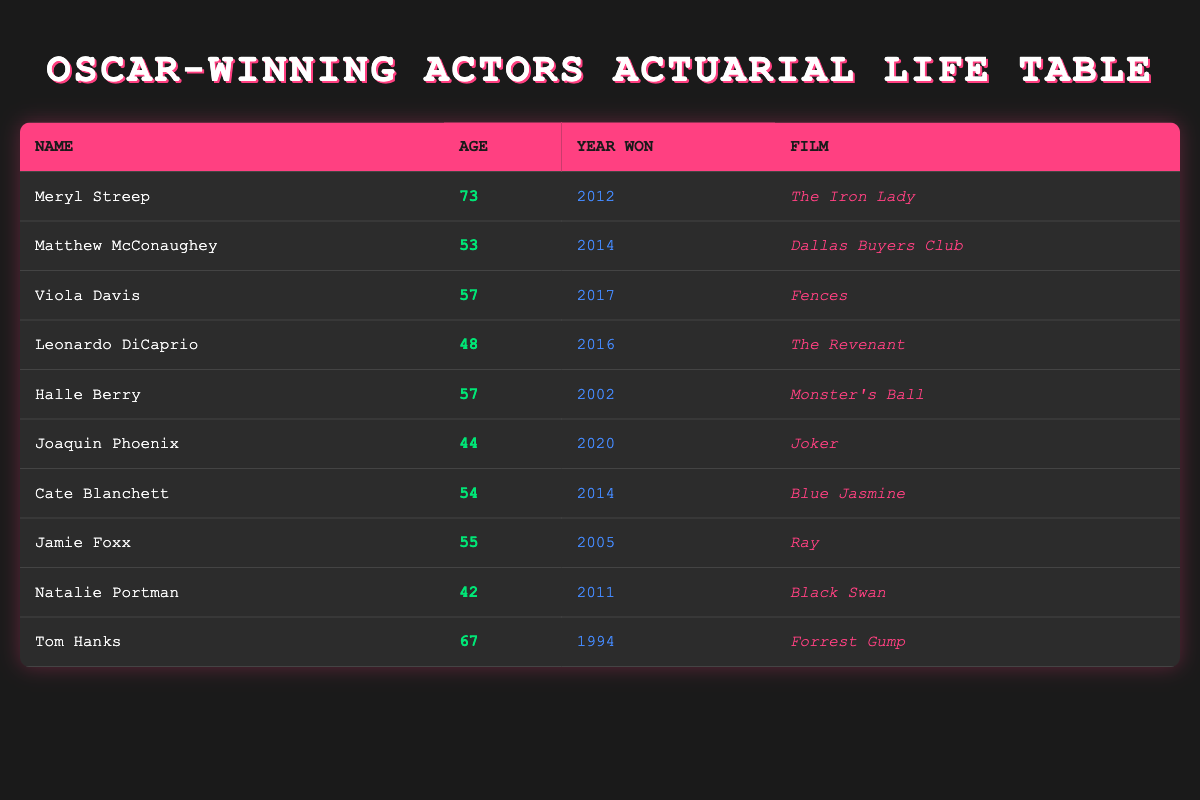What is the age of Meryl Streep when she won her Oscar? Meryl Streep's age is listed in the table as 73, which is directly taken from the "Age" column next to her name.
Answer: 73 Which film did Matthew McConaughey win his Oscar for? The table indicates that Matthew McConaughey won his Oscar for "Dallas Buyers Club", found in the "Film" column next to his name.
Answer: Dallas Buyers Club How many Oscar-winning actors and actresses are 50 years or older? Based on filtering, the actors and actresses with ages 50 or older are Meryl Streep (73), Matthew McConaughey (53), Viola Davis (57), Halle Berry (57), Jamie Foxx (55), and Tom Hanks (67). This totals to 6 individuals.
Answer: 6 What is the average age of the Oscar-winning actors and actresses listed in the table? To find the average age, we sum their ages: 73 + 53 + 57 + 48 + 57 + 44 + 54 + 55 + 42 + 67 = 450. There are 10 actors and actresses, so the average age is 450 / 10 = 45.
Answer: 45 Did anyone win an Oscar for a film released in the year 2014? The table shows both Matthew McConaughey and Cate Blanchett winning Oscars in 2014, for "Dallas Buyers Club" and "Blue Jasmine" respectively, confirming that yes, there are winners from that year.
Answer: Yes Who is the youngest Oscar-winning actor or actress in the table? By comparing ages, Natalie Portman at age 42 is the youngest, as her age is lower than all others listed.
Answer: Natalie Portman Which Oscar-winning actor has the highest age difference from Natalie Portman? Natalie Portman is 42, and Tom Hanks, who is 67, has the highest age difference: 67 - 42 = 25 years. Thus, he has the largest difference from her age amongst all entries.
Answer: 25 Is it true that all actors in the table have won an Oscar in a film released after 2000? Examining the release years shows that Tom Hanks won for "Forrest Gump" in 1994, indicating false for this claim, as not all films listed were released after 2000.
Answer: No 